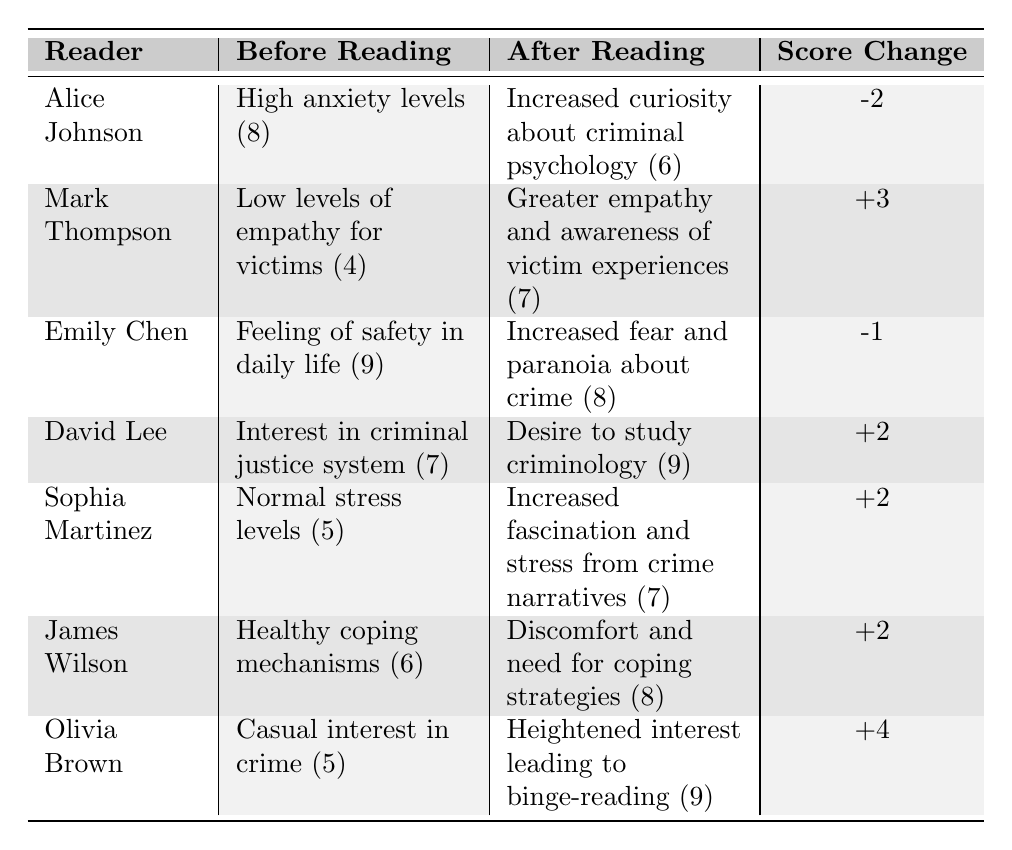What is the psychological effect reported by Alice Johnson after reading true crime stories? According to the table, after reading true crime stories, Alice Johnson reported an "Increased curiosity about criminal psychology."
Answer: Increased curiosity about criminal psychology How much did Mark Thompson's score change after reading true crime stories? Mark Thompson's score increased from 4 to 7 after reading, resulting in a change of +3.
Answer: +3 What was Emily Chen's psychological effect before reading true crime stories? The table states that before reading true crime stories, Emily Chen reported feeling "Feeling of safety in daily life."
Answer: Feeling of safety in daily life Which reader experienced the highest positive score change? Olivia Brown had a score increase from 5 to 9, which is a change of +4, the highest among all readers.
Answer: Olivia Brown Is it true that David Lee's interest in criminal justice increased after reading true crime stories? Yes, the table shows that David Lee's interest evolved into a "Desire to study criminology" after reading true crime stories.
Answer: Yes What was the average score change for all the readers? The score changes are -2, +3, -1, +2, +2, +2, and +4. Summing these gives 10, and dividing by 7 readers results in an average score change of approximately +1.43.
Answer: +1.43 Which psychological effect reported after reading true crime stories indicates an increase in stress levels? Sophia Martinez reported "Increased fascination and stress from crime narratives," indicating that her stress levels increased after reading.
Answer: Increased fascination and stress from crime narratives Did anyone report a decrease in reported score after reading true crime stories? Yes, Alice Johnson's score decreased from 8 to 6, which is a decrease of -2.
Answer: Yes What was the reported score of James Wilson before he engaged with true crime stories? James Wilson reported a score of 6 before reading true crime stories.
Answer: 6 How many readers reported a psychological effect related to crime awareness? Two readers, Mark Thompson and David Lee, reported psychological effects related to crime awareness (greater empathy and desire to study criminology).
Answer: 2 